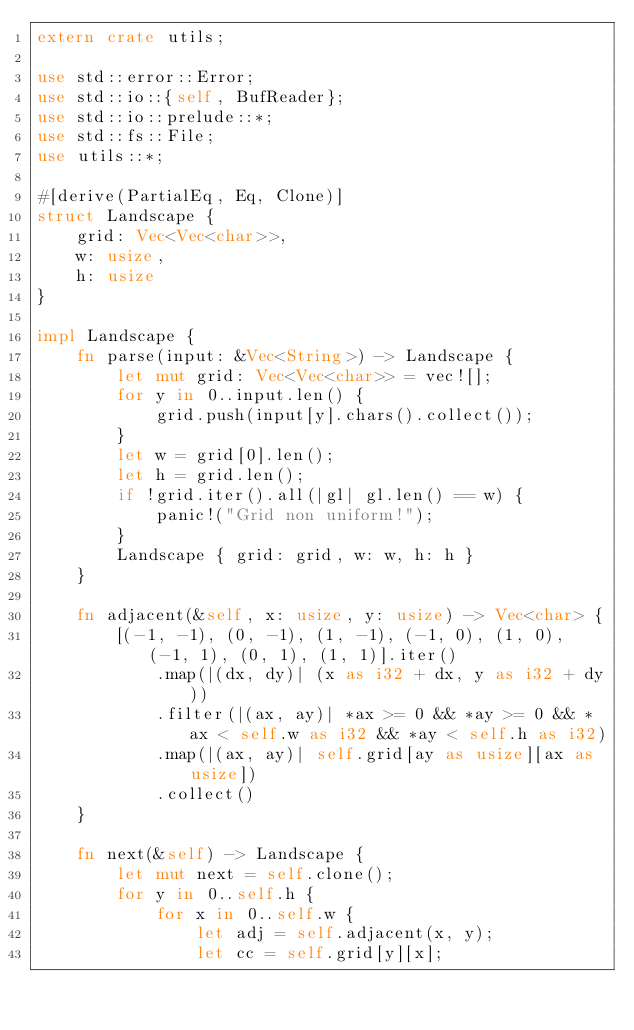Convert code to text. <code><loc_0><loc_0><loc_500><loc_500><_Rust_>extern crate utils;

use std::error::Error;
use std::io::{self, BufReader};
use std::io::prelude::*;
use std::fs::File;
use utils::*;

#[derive(PartialEq, Eq, Clone)]
struct Landscape {
    grid: Vec<Vec<char>>,
    w: usize,
    h: usize
}

impl Landscape {
    fn parse(input: &Vec<String>) -> Landscape {
        let mut grid: Vec<Vec<char>> = vec![];
        for y in 0..input.len() {
            grid.push(input[y].chars().collect());
        }
        let w = grid[0].len();
        let h = grid.len();
        if !grid.iter().all(|gl| gl.len() == w) {
            panic!("Grid non uniform!");
        }
        Landscape { grid: grid, w: w, h: h }
    }

    fn adjacent(&self, x: usize, y: usize) -> Vec<char> {
        [(-1, -1), (0, -1), (1, -1), (-1, 0), (1, 0), (-1, 1), (0, 1), (1, 1)].iter()
            .map(|(dx, dy)| (x as i32 + dx, y as i32 + dy))
            .filter(|(ax, ay)| *ax >= 0 && *ay >= 0 && *ax < self.w as i32 && *ay < self.h as i32)
            .map(|(ax, ay)| self.grid[ay as usize][ax as usize])
            .collect()
    }

    fn next(&self) -> Landscape {
        let mut next = self.clone();
        for y in 0..self.h {
            for x in 0..self.w {
                let adj = self.adjacent(x, y);
                let cc = self.grid[y][x];</code> 